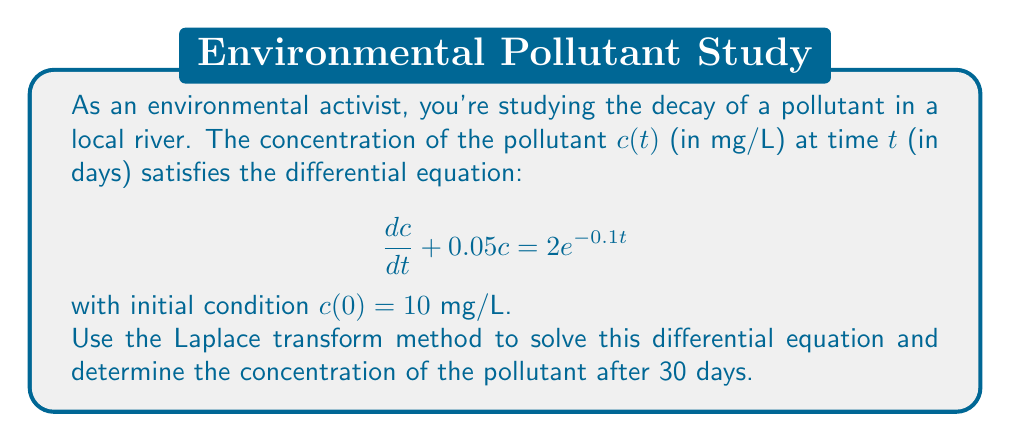Solve this math problem. Let's solve this using the Laplace transform method:

1) Take the Laplace transform of both sides of the equation:
   $$\mathcal{L}\left\{\frac{dc}{dt} + 0.05c\right\} = \mathcal{L}\{2e^{-0.1t}\}$$

2) Using Laplace transform properties:
   $$sC(s) - c(0) + 0.05C(s) = \frac{2}{s+0.1}$$
   where $C(s) = \mathcal{L}\{c(t)\}$

3) Substitute the initial condition $c(0) = 10$:
   $$sC(s) - 10 + 0.05C(s) = \frac{2}{s+0.1}$$

4) Solve for $C(s)$:
   $$(s + 0.05)C(s) = 10 + \frac{2}{s+0.1}$$
   $$C(s) = \frac{10}{s + 0.05} + \frac{2}{(s + 0.05)(s + 0.1)}$$

5) Decompose into partial fractions:
   $$C(s) = \frac{10}{s + 0.05} + \frac{4}{s + 0.05} - \frac{4}{s + 0.1}$$

6) Take the inverse Laplace transform:
   $$c(t) = 14e^{-0.05t} - 4e^{-0.1t}$$

7) To find the concentration after 30 days, substitute $t = 30$:
   $$c(30) = 14e^{-0.05(30)} - 4e^{-0.1(30)}$$
   $$c(30) = 14e^{-1.5} - 4e^{-3}$$
   $$c(30) \approx 3.14 - 0.20 = 2.94$$
Answer: $2.94$ mg/L 